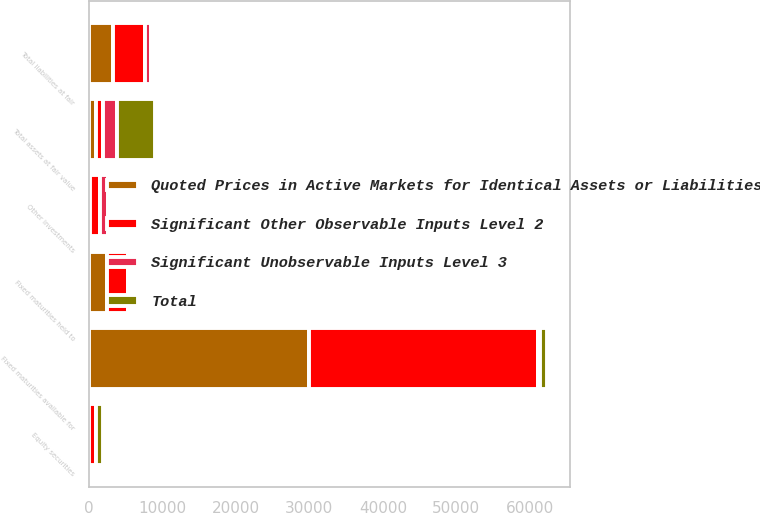Convert chart to OTSL. <chart><loc_0><loc_0><loc_500><loc_500><stacked_bar_chart><ecel><fcel>Fixed maturities available for<fcel>Fixed maturities held to<fcel>Equity securities<fcel>Other investments<fcel>Total assets at fair value<fcel>Total liabilities at fair<nl><fcel>Total<fcel>872<fcel>332<fcel>962<fcel>37<fcel>5089<fcel>3<nl><fcel>Quoted Prices in Active Markets for Identical Assets or Liabilities Level 1<fcel>30009<fcel>2532<fcel>5<fcel>226<fcel>975<fcel>3344<nl><fcel>Significant Unobservable Inputs Level 3<fcel>274<fcel>1<fcel>21<fcel>1099<fcel>1917<fcel>910<nl><fcel>Significant Other Observable Inputs Level 2<fcel>31155<fcel>2865<fcel>988<fcel>1362<fcel>975<fcel>4257<nl></chart> 